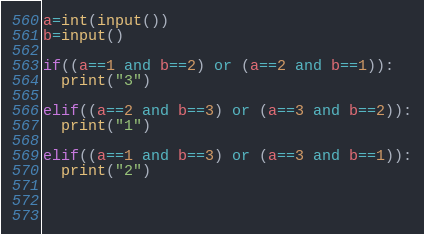Convert code to text. <code><loc_0><loc_0><loc_500><loc_500><_Python_>a=int(input())
b=input()

if((a==1 and b==2) or (a==2 and b==1)):
  print("3")
  
elif((a==2 and b==3) or (a==3 and b==2)):
  print("1")
  
elif((a==1 and b==3) or (a==3 and b==1)):
  print("2")
  

  
</code> 